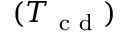Convert formula to latex. <formula><loc_0><loc_0><loc_500><loc_500>( T _ { c d } )</formula> 